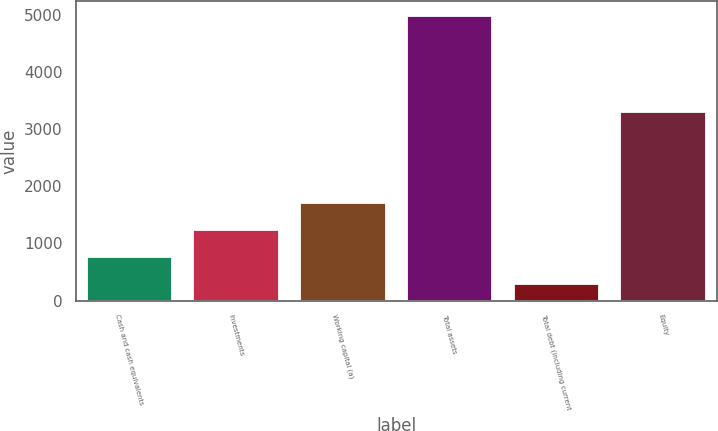Convert chart to OTSL. <chart><loc_0><loc_0><loc_500><loc_500><bar_chart><fcel>Cash and cash equivalents<fcel>Investments<fcel>Working capital (a)<fcel>Total assets<fcel>Total debt (including current<fcel>Equity<nl><fcel>759.9<fcel>1228.8<fcel>1697.7<fcel>4980<fcel>291<fcel>3305<nl></chart> 